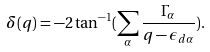Convert formula to latex. <formula><loc_0><loc_0><loc_500><loc_500>\delta ( q ) = - 2 \tan ^ { - 1 } ( \sum _ { \alpha } \frac { \Gamma _ { \alpha } } { q - \epsilon _ { d \alpha } } ) .</formula> 